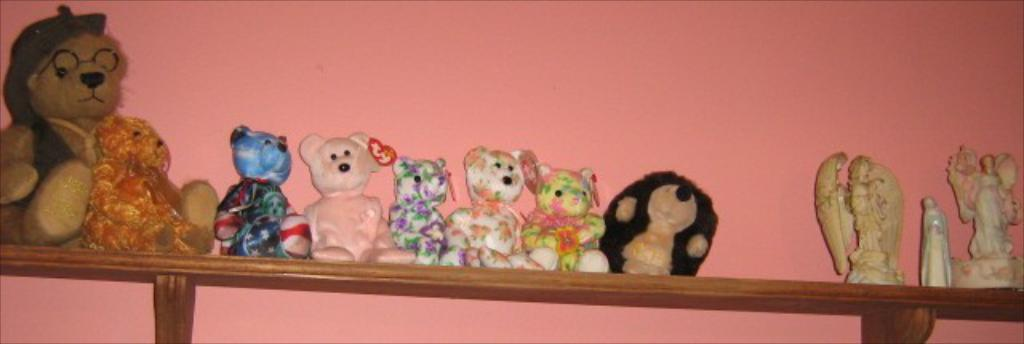What type of objects are present in the image? There are soft toys in the image. How are the toys arranged in the image? The toys are on wooden planks in the image. Are the wooden planks attached to anything? Yes, the wooden planks are fixed to a wall. What color is the wall in the background? The wall in the background is pink. What type of parcel is being delivered to the space station in the image? There is no parcel or space station present in the image; it features soft toys on wooden planks fixed to a pink wall. 